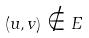<formula> <loc_0><loc_0><loc_500><loc_500>( u , v ) \notin E</formula> 